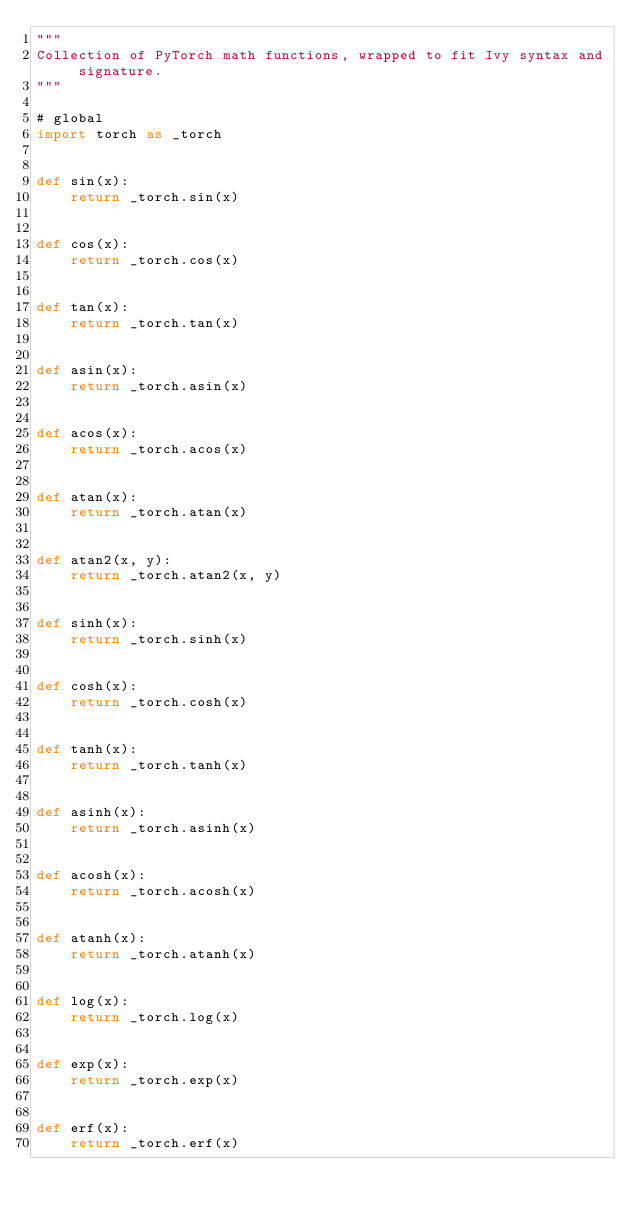Convert code to text. <code><loc_0><loc_0><loc_500><loc_500><_Python_>"""
Collection of PyTorch math functions, wrapped to fit Ivy syntax and signature.
"""

# global
import torch as _torch


def sin(x):
    return _torch.sin(x)


def cos(x):
    return _torch.cos(x)


def tan(x):
    return _torch.tan(x)


def asin(x):
    return _torch.asin(x)


def acos(x):
    return _torch.acos(x)


def atan(x):
    return _torch.atan(x)


def atan2(x, y):
    return _torch.atan2(x, y)


def sinh(x):
    return _torch.sinh(x)


def cosh(x):
    return _torch.cosh(x)


def tanh(x):
    return _torch.tanh(x)


def asinh(x):
    return _torch.asinh(x)


def acosh(x):
    return _torch.acosh(x)


def atanh(x):
    return _torch.atanh(x)


def log(x):
    return _torch.log(x)


def exp(x):
    return _torch.exp(x)


def erf(x):
    return _torch.erf(x)
</code> 